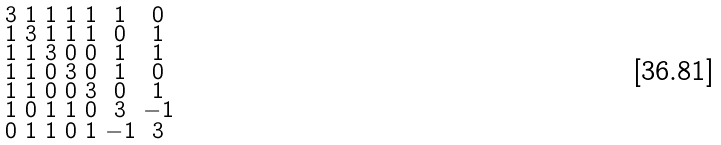Convert formula to latex. <formula><loc_0><loc_0><loc_500><loc_500>\begin{smallmatrix} 3 & 1 & 1 & 1 & 1 & 1 & 0 \\ 1 & 3 & 1 & 1 & 1 & 0 & 1 \\ 1 & 1 & 3 & 0 & 0 & 1 & 1 \\ 1 & 1 & 0 & 3 & 0 & 1 & 0 \\ 1 & 1 & 0 & 0 & 3 & 0 & 1 \\ 1 & 0 & 1 & 1 & 0 & 3 & - 1 \\ 0 & 1 & 1 & 0 & 1 & - 1 & 3 \end{smallmatrix}</formula> 